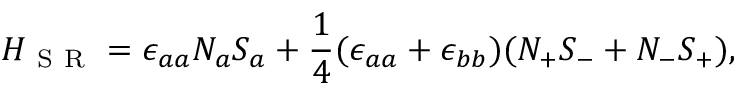<formula> <loc_0><loc_0><loc_500><loc_500>H _ { S R } = \epsilon _ { a a } N _ { a } S _ { a } + \frac { 1 } { 4 } ( \epsilon _ { a a } + \epsilon _ { b b } ) ( N _ { + } S _ { - } + N _ { - } S _ { + } ) ,</formula> 